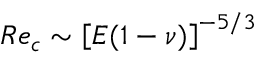<formula> <loc_0><loc_0><loc_500><loc_500>R e _ { c } \sim \left [ E ( 1 - \nu ) \right ] ^ { - 5 / 3 }</formula> 